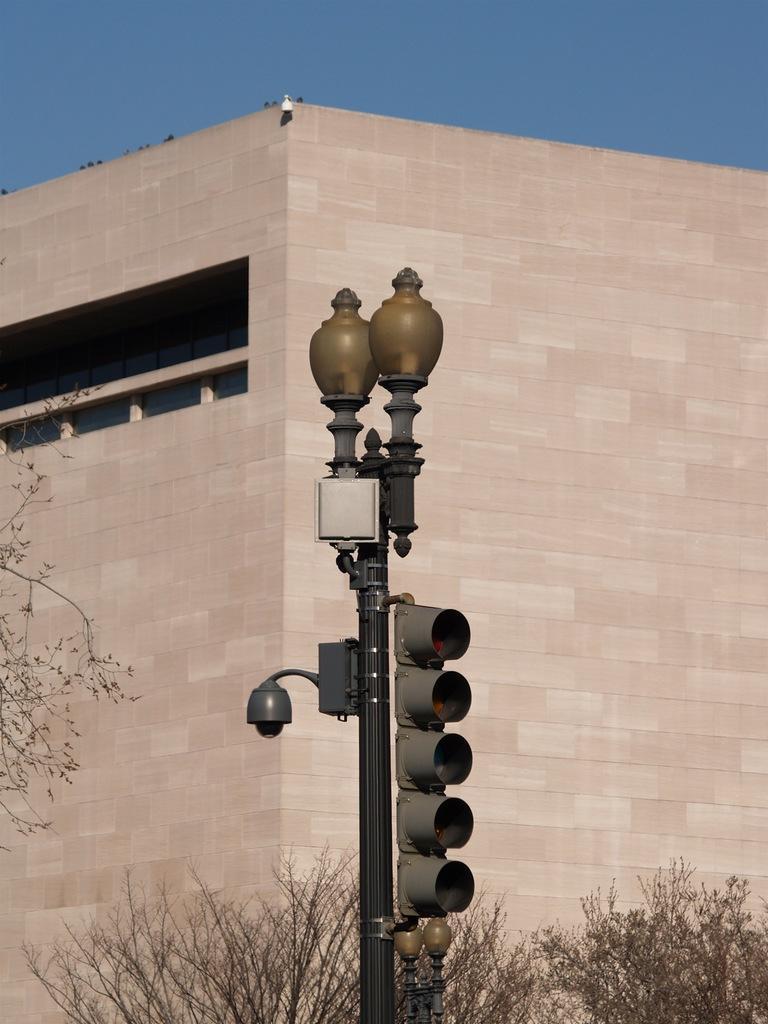How would you summarize this image in a sentence or two? In this picture there is a black pole. On the pole we can see traffic signal, light, camera and speaker. On the bottom we can see plants. In the background there is a building. On the left there is a tree. On the top there is a sky. 